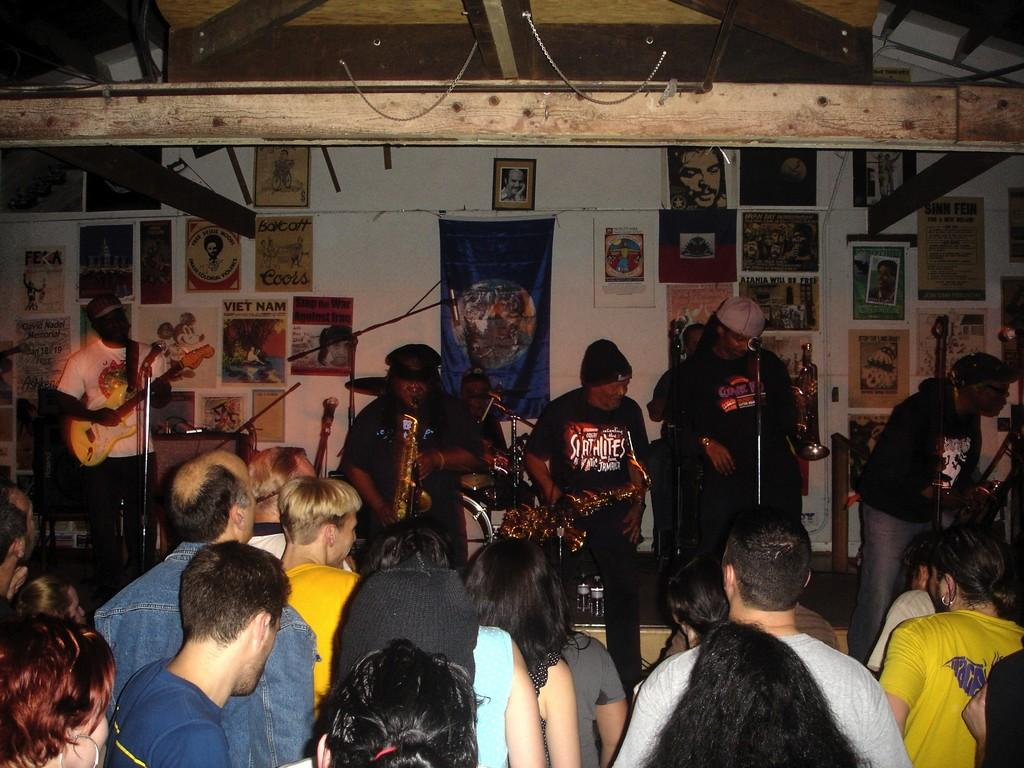How many people are in the image? There is a group of people in the image, but the exact number is not specified. What are the people in the image doing? The presence of musical instruments suggests that the people might be playing music or participating in a musical event. What can be seen in the background of the image? There is a wall, a banner, posters, and some unspecified objects in the background of the image. What type of seed is being used to create humor in the image? There is no seed or humor present in the image; it features a group of people and musical instruments. What is the current temperature in the image? The image does not provide any information about the temperature or weather conditions. 